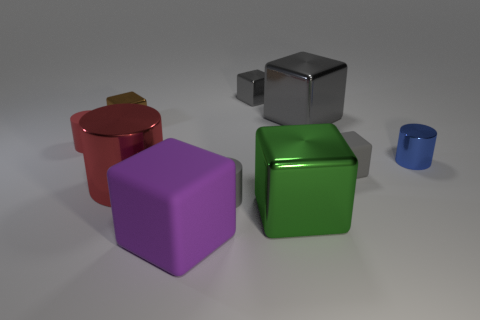Subtract all purple balls. How many gray blocks are left? 3 Subtract all purple blocks. How many blocks are left? 5 Subtract all big metal blocks. How many blocks are left? 4 Subtract all green blocks. Subtract all green balls. How many blocks are left? 5 Subtract all cylinders. How many objects are left? 6 Add 3 large gray things. How many large gray things exist? 4 Subtract 1 green cubes. How many objects are left? 9 Subtract all large brown metal cylinders. Subtract all blue metallic things. How many objects are left? 9 Add 7 brown blocks. How many brown blocks are left? 8 